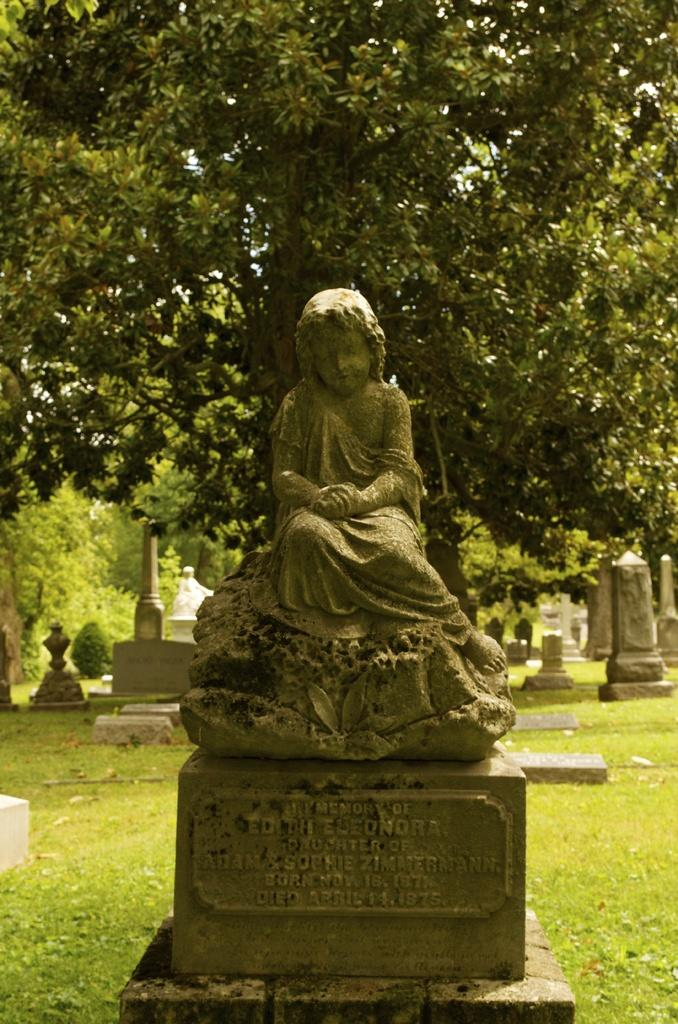What is the main feature in the middle of the garden? There is a statue in the middle of the garden. What can be seen behind the main statue? There is a tree behind the statue. Are there any other statues in the garden? Yes, there are statues on either side of the main statue. How many sticks are leaning against the statue in the image? There are no sticks leaning against the statue in the image. What type of science is being demonstrated by the statues in the garden? The statues in the garden are not demonstrating any scientific concepts; they are simply sculptures. 